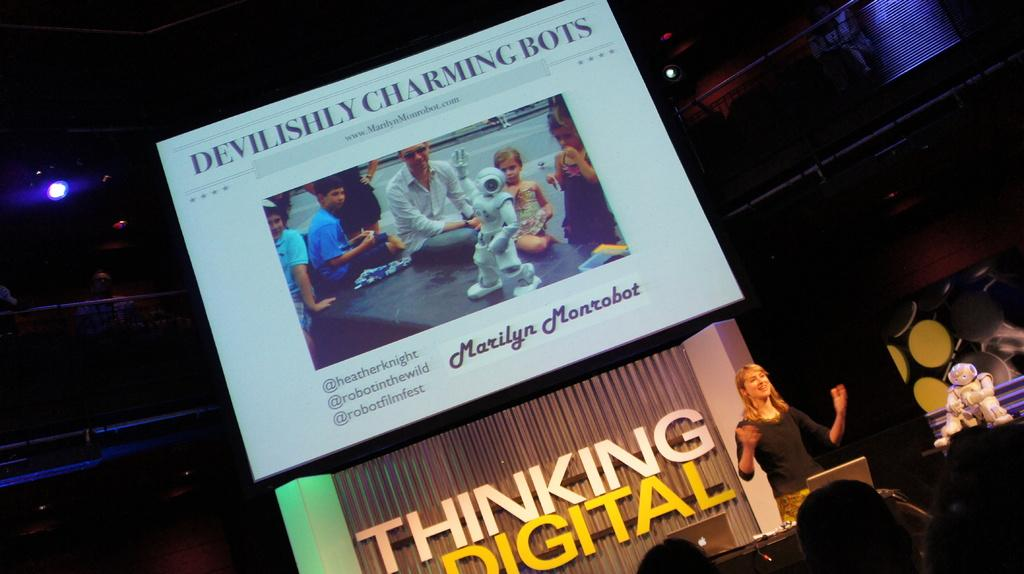<image>
Render a clear and concise summary of the photo. A woman at a podium in front of a wall stating THINKING DIGITAL with a slide above it titled DEVILISHLY CHARMING BOTS. 